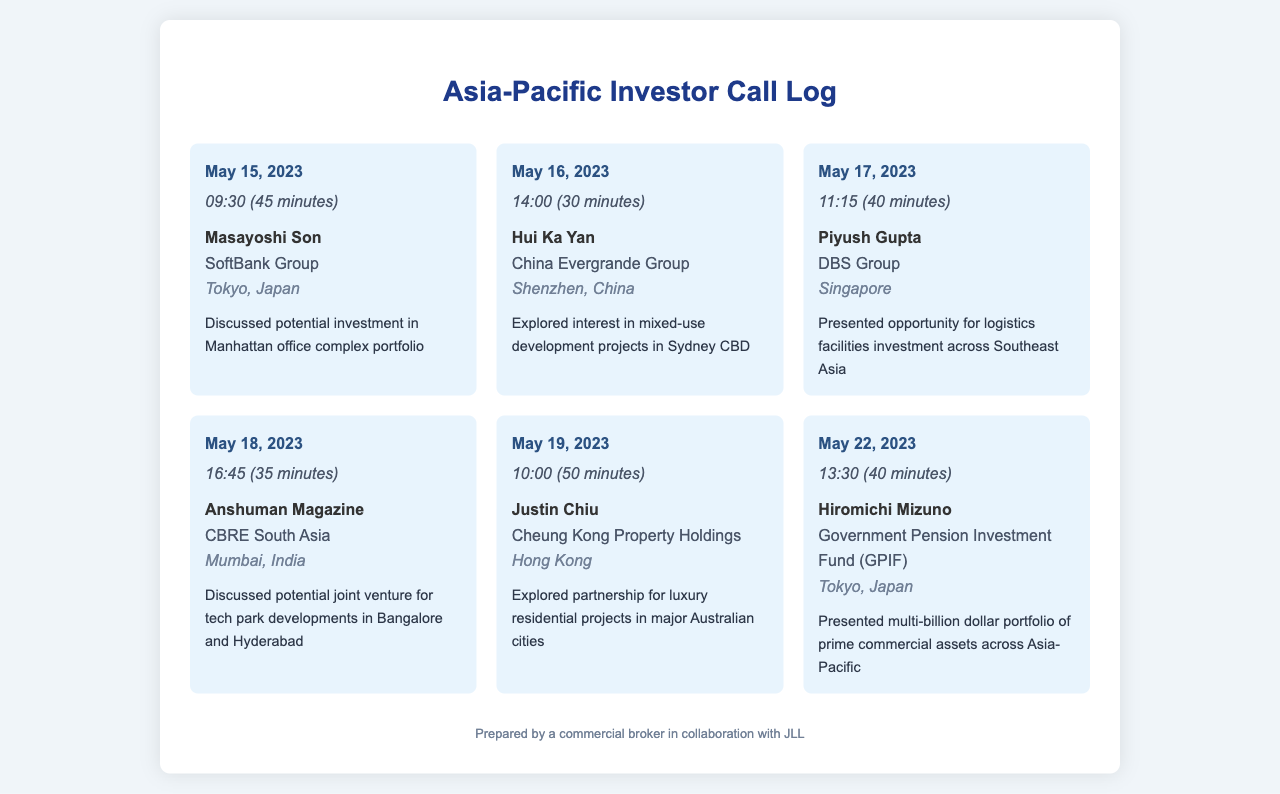What is the date of the call with Masayoshi Son? The date is specified directly in the call log entry for Masayoshi Son.
Answer: May 15, 2023 Who is the contact for the call on May 16, 2023? The contact for this call is identified under the call log for that date.
Answer: Hui Ka Yan What company does Piyush Gupta represent? The company is mentioned in the call log entry for Piyush Gupta.
Answer: DBS Group How long was the call with Hiromichi Mizuno? The duration of the call is specified in the entry for Hiromichi Mizuno.
Answer: 40 minutes What location is associated with the call on May 19, 2023? The location is listed in the call log for that specific date.
Answer: Hong Kong Which investor discussed a potential joint venture in Bangalore? The investor's name is stated in the entry that discusses a joint venture for tech park developments.
Answer: Anshuman Magazine What type of development projects were discussed with Hui Ka Yan? The type of projects is mentioned in the notes for the call with Hui Ka Yan.
Answer: Mixed-use development projects How many minutes did the call on May 17, 2023, last? The duration is directly recorded in the call log entry for that date.
Answer: 40 minutes What was presented during the call with Hiromichi Mizuno? The content of the presentation is noted in the call log for Hiromichi Mizuno.
Answer: Multi-billion dollar portfolio of prime commercial assets across Asia-Pacific 